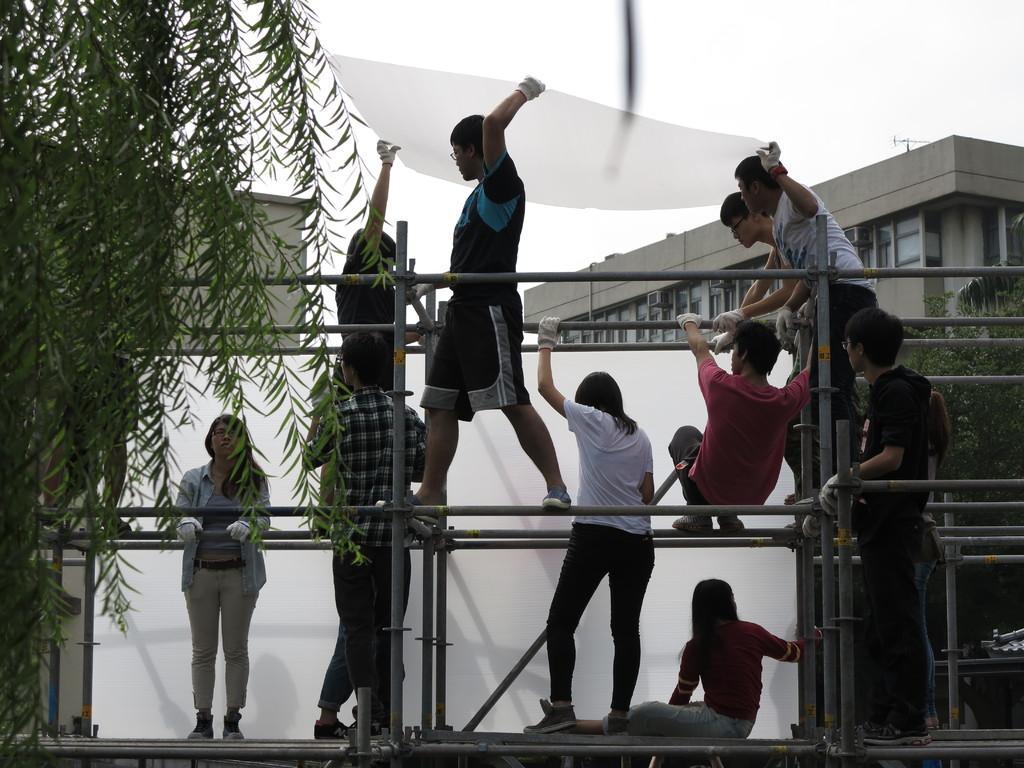Please provide a concise description of this image. In this picture I can see group of people among them some are standing and some are sitting. I can also see some poles. In the background I can see buildings. 